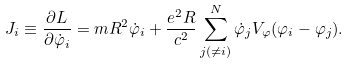<formula> <loc_0><loc_0><loc_500><loc_500>J _ { i } \equiv \frac { \partial L } { \partial \dot { \varphi } _ { i } } = m R ^ { 2 } \dot { \varphi } _ { i } + \frac { e ^ { 2 } R } { c ^ { 2 } } \sum _ { j ( \neq i ) } ^ { N } \dot { \varphi } _ { j } V _ { \varphi } ( \varphi _ { i } - \varphi _ { j } ) .</formula> 